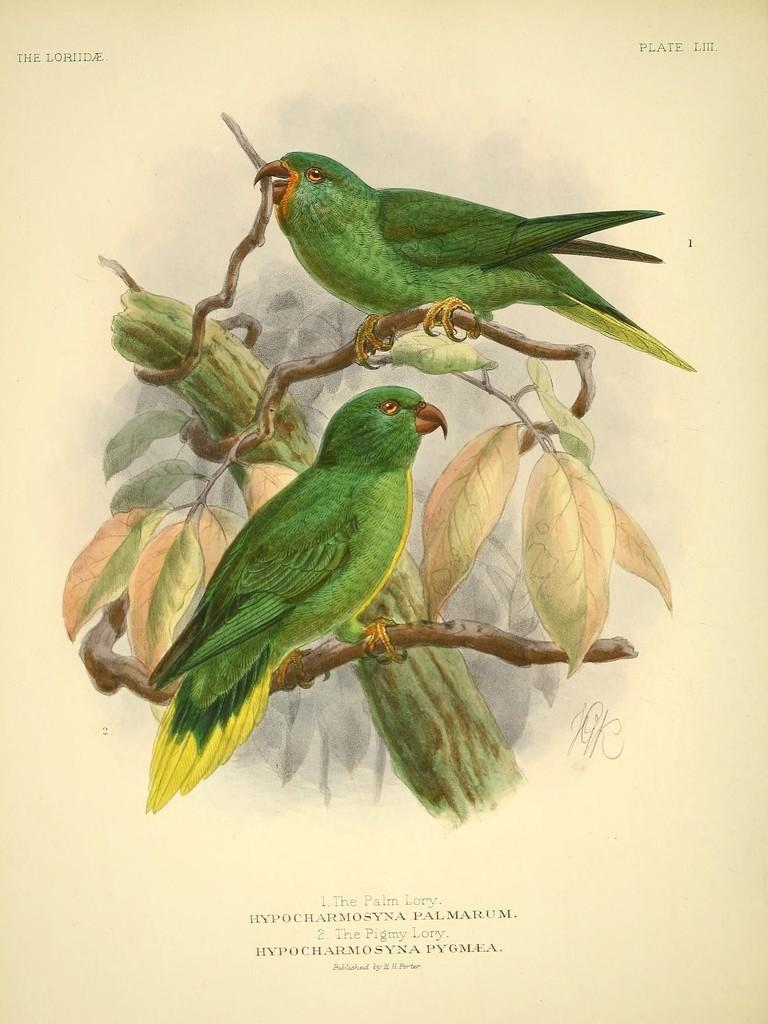What type of artwork is depicted in the image? The image is a painting. What animals are featured in the painting? There are parrots in the image. Where are the parrots located in the painting? The parrots are on a tree branch. Is there any text included in the painting? Yes, there is text written at the bottom of the image. What type of debt is being discussed in the painting? There is no mention of debt in the painting; it features parrots on a tree branch and text at the bottom. What tools might a carpenter use in the painting? There are no carpenters or tools present in the painting; it focuses on parrots and text. 